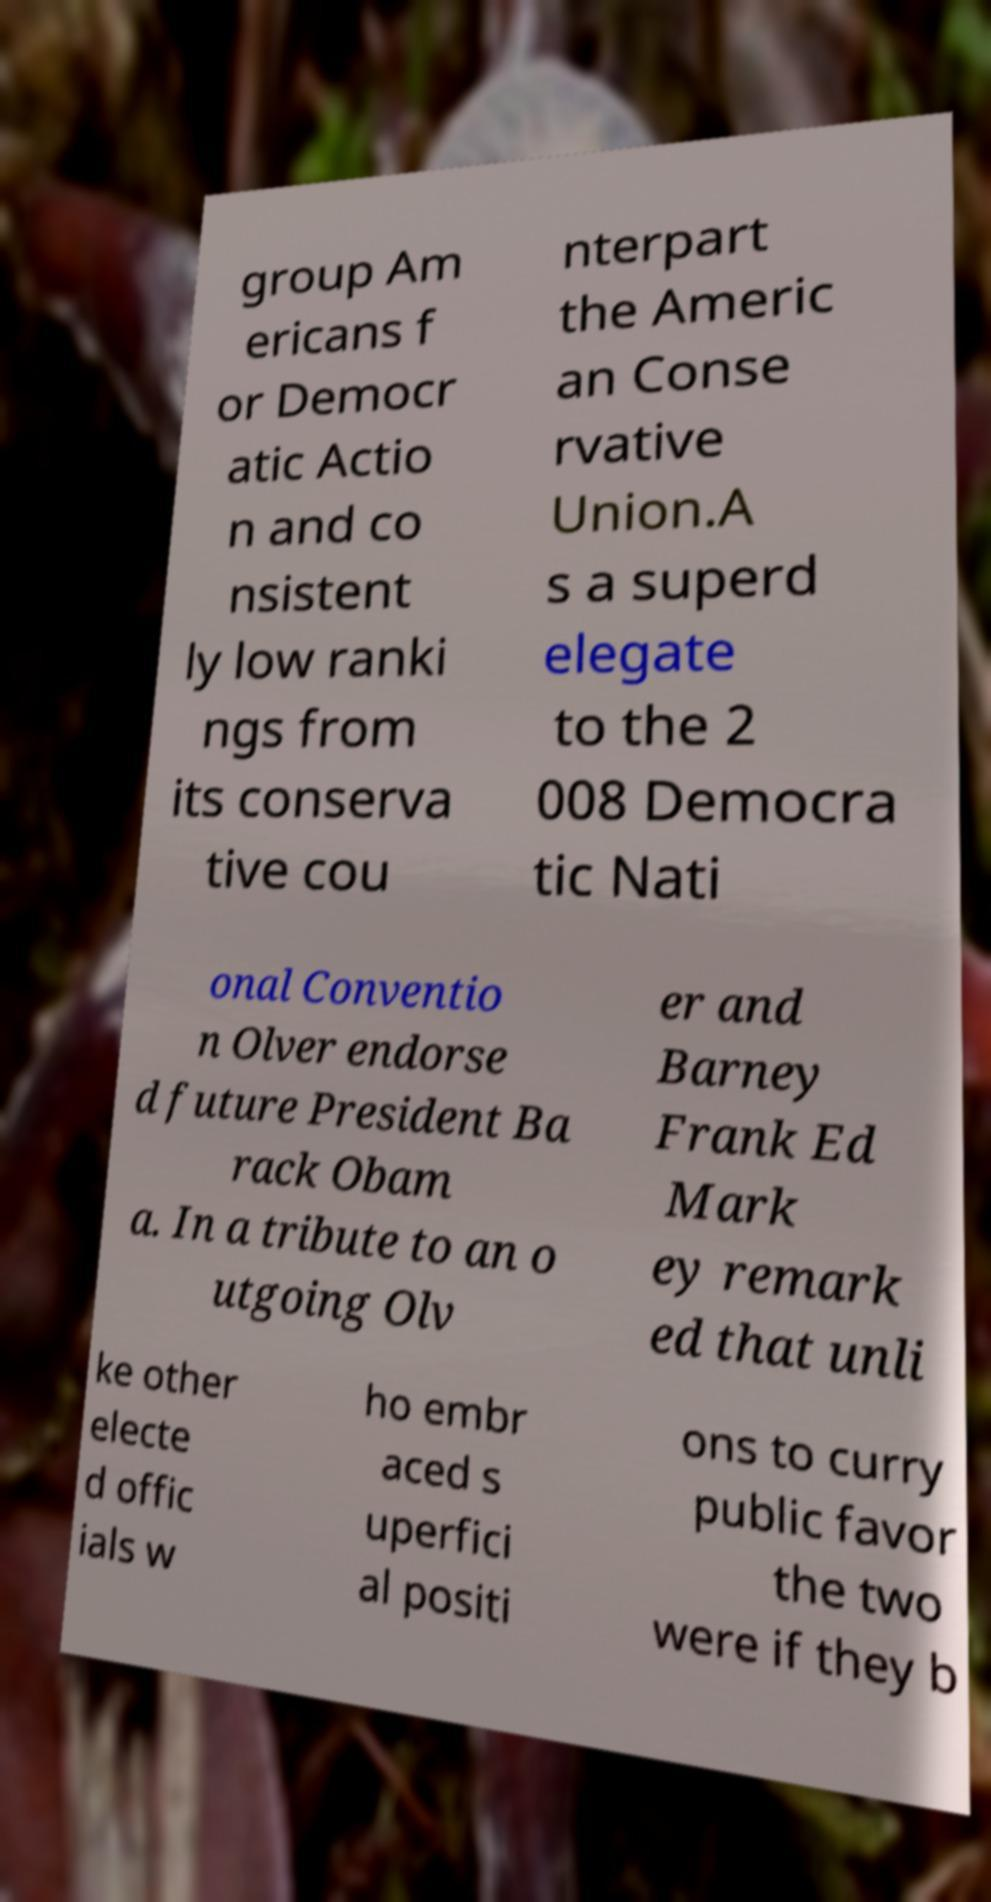Could you assist in decoding the text presented in this image and type it out clearly? group Am ericans f or Democr atic Actio n and co nsistent ly low ranki ngs from its conserva tive cou nterpart the Americ an Conse rvative Union.A s a superd elegate to the 2 008 Democra tic Nati onal Conventio n Olver endorse d future President Ba rack Obam a. In a tribute to an o utgoing Olv er and Barney Frank Ed Mark ey remark ed that unli ke other electe d offic ials w ho embr aced s uperfici al positi ons to curry public favor the two were if they b 